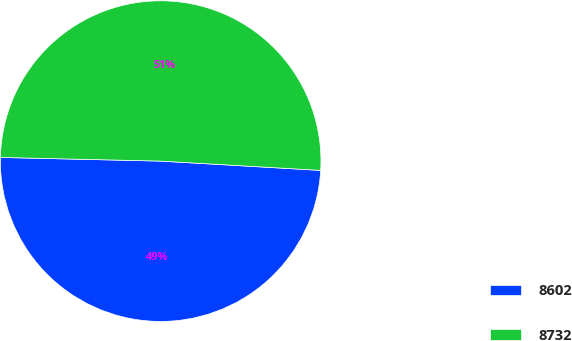Convert chart. <chart><loc_0><loc_0><loc_500><loc_500><pie_chart><fcel>8602<fcel>8732<nl><fcel>49.44%<fcel>50.56%<nl></chart> 